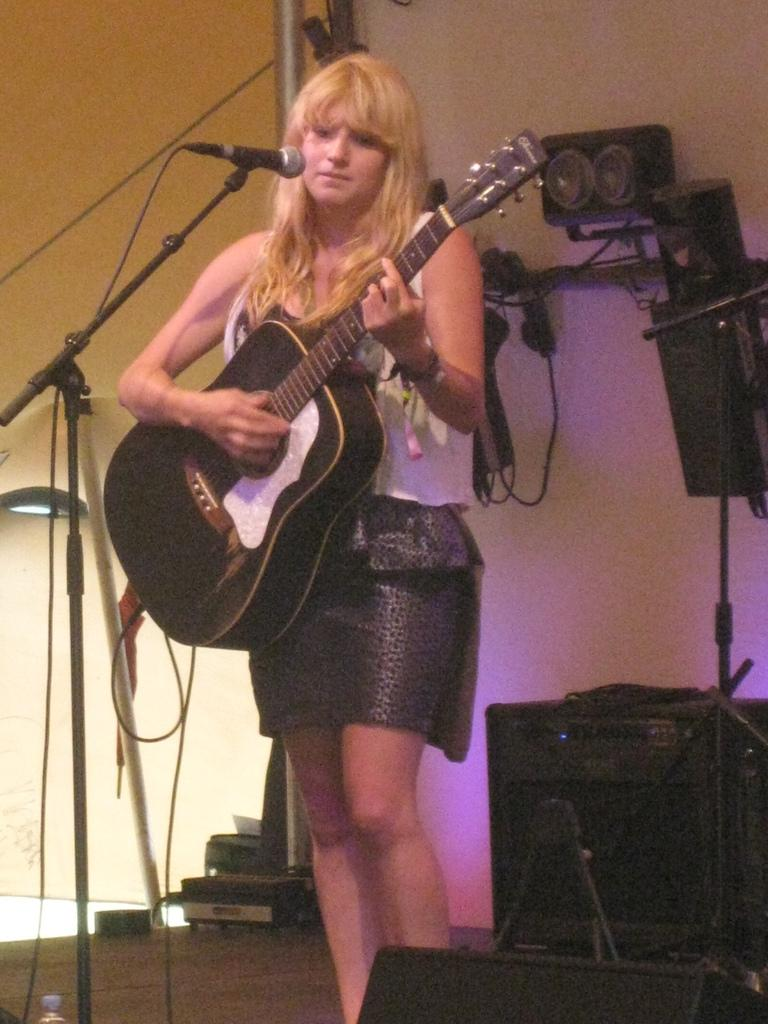Who is the main subject in the image? There is a woman in the image. Where is the woman located in the image? The woman is standing on a stage. What is the woman doing in the image? The woman is playing a guitar. What is the guitar positioned near in the image? The guitar is in front of a microphone and stand. What can be seen in the background of the image? There are speakers and a wall visible in the background of the image. Can you see a hose attached to the guitar in the image? No, there is no hose attached to the guitar in the image. Does the woman have wings in the image? No, the woman does not have wings in the image. 